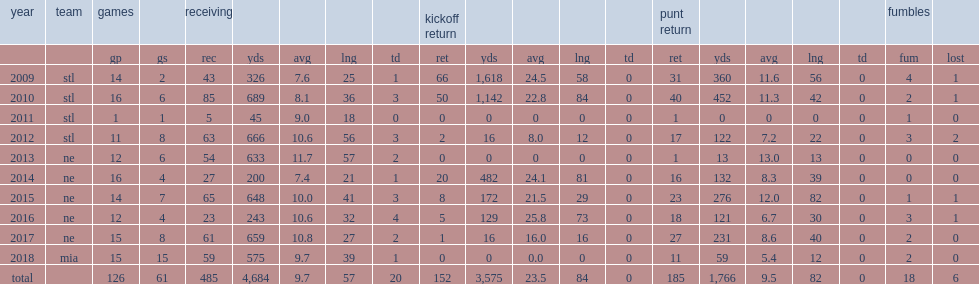How many kickoff yards did danny amendola get in 2009? 1618.0. 